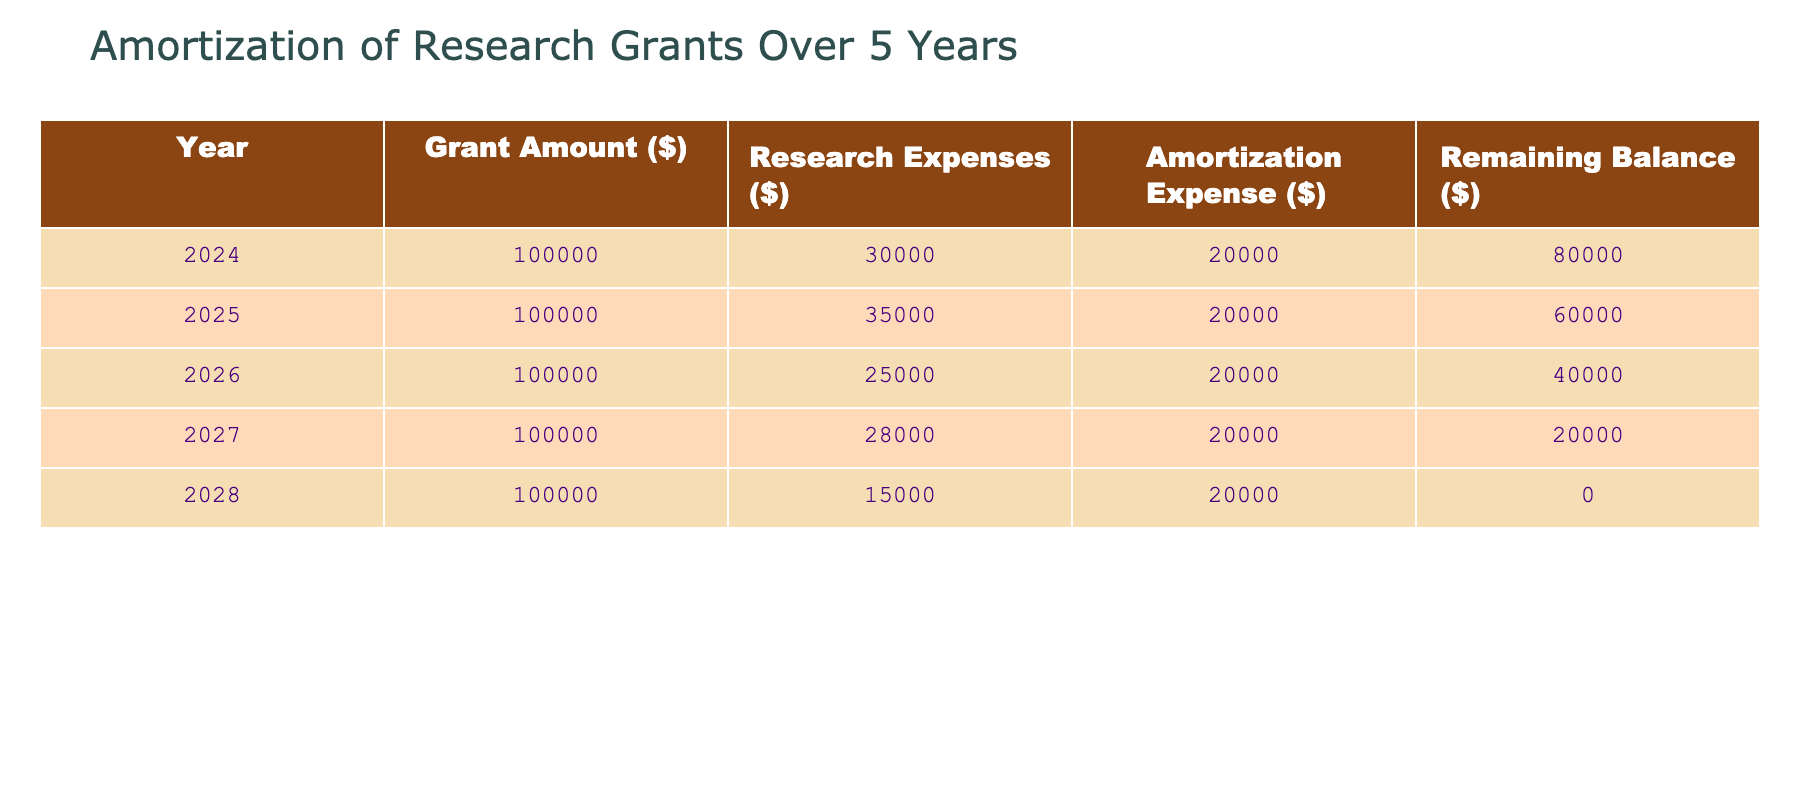What is the total grant amount provided for the five years? The grant amount is consistent at $100,000 each year for five years, so we multiply $100,000 by 5, which gives us $500,000.
Answer: 500000 In which year were the research expenses the highest? By examining the 'Research Expenses ($)' column, we find that the highest value is for the year 2025, with $35,000.
Answer: 2025 What is the total amortization expense over the five years? The amortization expense is constant at $20,000 each year. Therefore, multiplying $20,000 by 5 results in $100,000.
Answer: 100000 Is the remaining balance after the last year (2028) zero? The remaining balance for 2028 is shown as $0. This means that all the grant money has been amortized by the end of that year.
Answer: Yes What is the average annual research expense across the five years? To find the average, we sum the research expenses: 30,000 + 35,000 + 25,000 + 28,000 + 15,000 = 133,000. Dividing this sum by 5 gives an average of $26,600.
Answer: 26600 What was the change in the remaining balance from 2024 to 2025? The remaining balance in 2024 is $80,000, and in 2025 it decreases to $60,000. The change is $80,000 - $60,000 = $20,000, indicating a reduction.
Answer: 20000 Which year had the lowest research expenses and what was the amount? In the table, the lowest research expense is in 2028 with an amount of $15,000.
Answer: 2028, 15000 If the pattern of amortization expenses continues, what will the remaining balance be after the fourth year? The remaining balance after the fourth year (2027) is $20,000, as shown in the table.
Answer: 20000 In which year was the amortization expense equaled to the research expenses? The amortization expense remains constant at $20,000, while only in 2026 do research expenses equal this at $25,000. Hence, it never exactly matches in any year.
Answer: No 